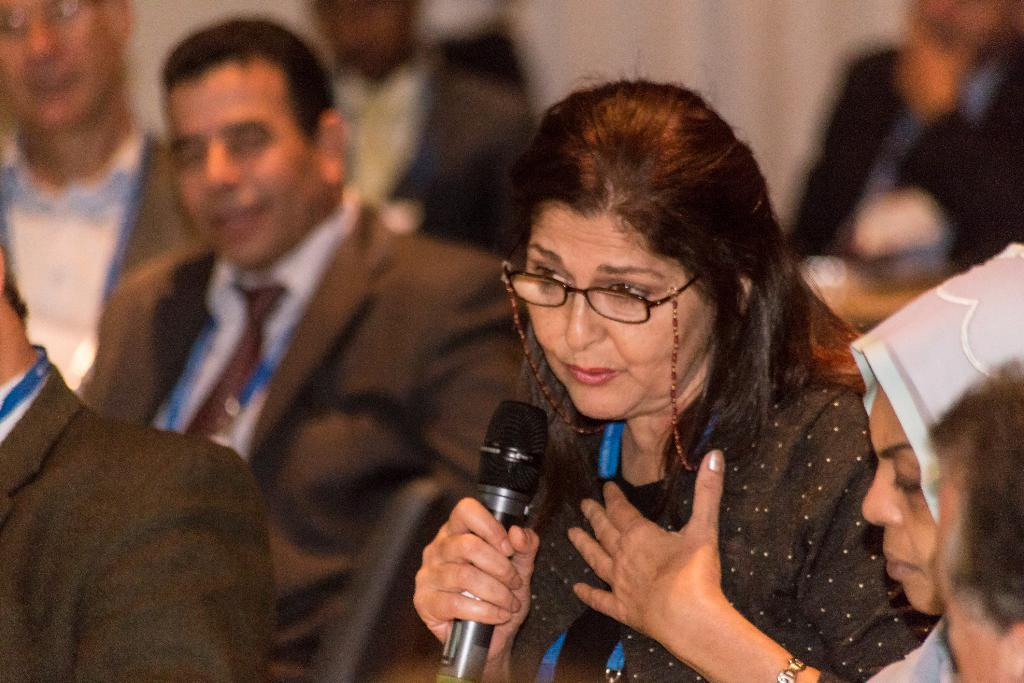What is the main subject of the image? The main subject of the image is a group of people. Can you describe any specific individuals in the group? Yes, there is a woman in the group. What is the woman holding in the image? The woman is holding a microphone. What type of insect can be seen crawling on the woman's finger in the image? There is no insect present on the woman's finger in the image. Can you describe the garden where the group is standing in the image? There is no garden present in the image; it features a group of people with a woman holding a microphone. 